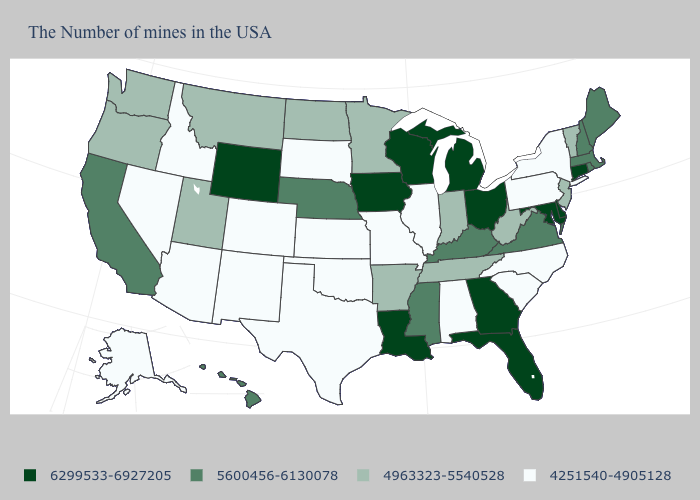Is the legend a continuous bar?
Quick response, please. No. What is the lowest value in the USA?
Be succinct. 4251540-4905128. What is the lowest value in the USA?
Give a very brief answer. 4251540-4905128. How many symbols are there in the legend?
Answer briefly. 4. What is the lowest value in the USA?
Quick response, please. 4251540-4905128. Is the legend a continuous bar?
Concise answer only. No. Name the states that have a value in the range 5600456-6130078?
Be succinct. Maine, Massachusetts, Rhode Island, New Hampshire, Virginia, Kentucky, Mississippi, Nebraska, California, Hawaii. Which states have the lowest value in the South?
Write a very short answer. North Carolina, South Carolina, Alabama, Oklahoma, Texas. What is the value of Minnesota?
Keep it brief. 4963323-5540528. Name the states that have a value in the range 4963323-5540528?
Be succinct. Vermont, New Jersey, West Virginia, Indiana, Tennessee, Arkansas, Minnesota, North Dakota, Utah, Montana, Washington, Oregon. What is the value of Connecticut?
Give a very brief answer. 6299533-6927205. Does the map have missing data?
Short answer required. No. What is the highest value in the USA?
Quick response, please. 6299533-6927205. Among the states that border New Jersey , does New York have the highest value?
Short answer required. No. Among the states that border Nevada , does Oregon have the highest value?
Concise answer only. No. 